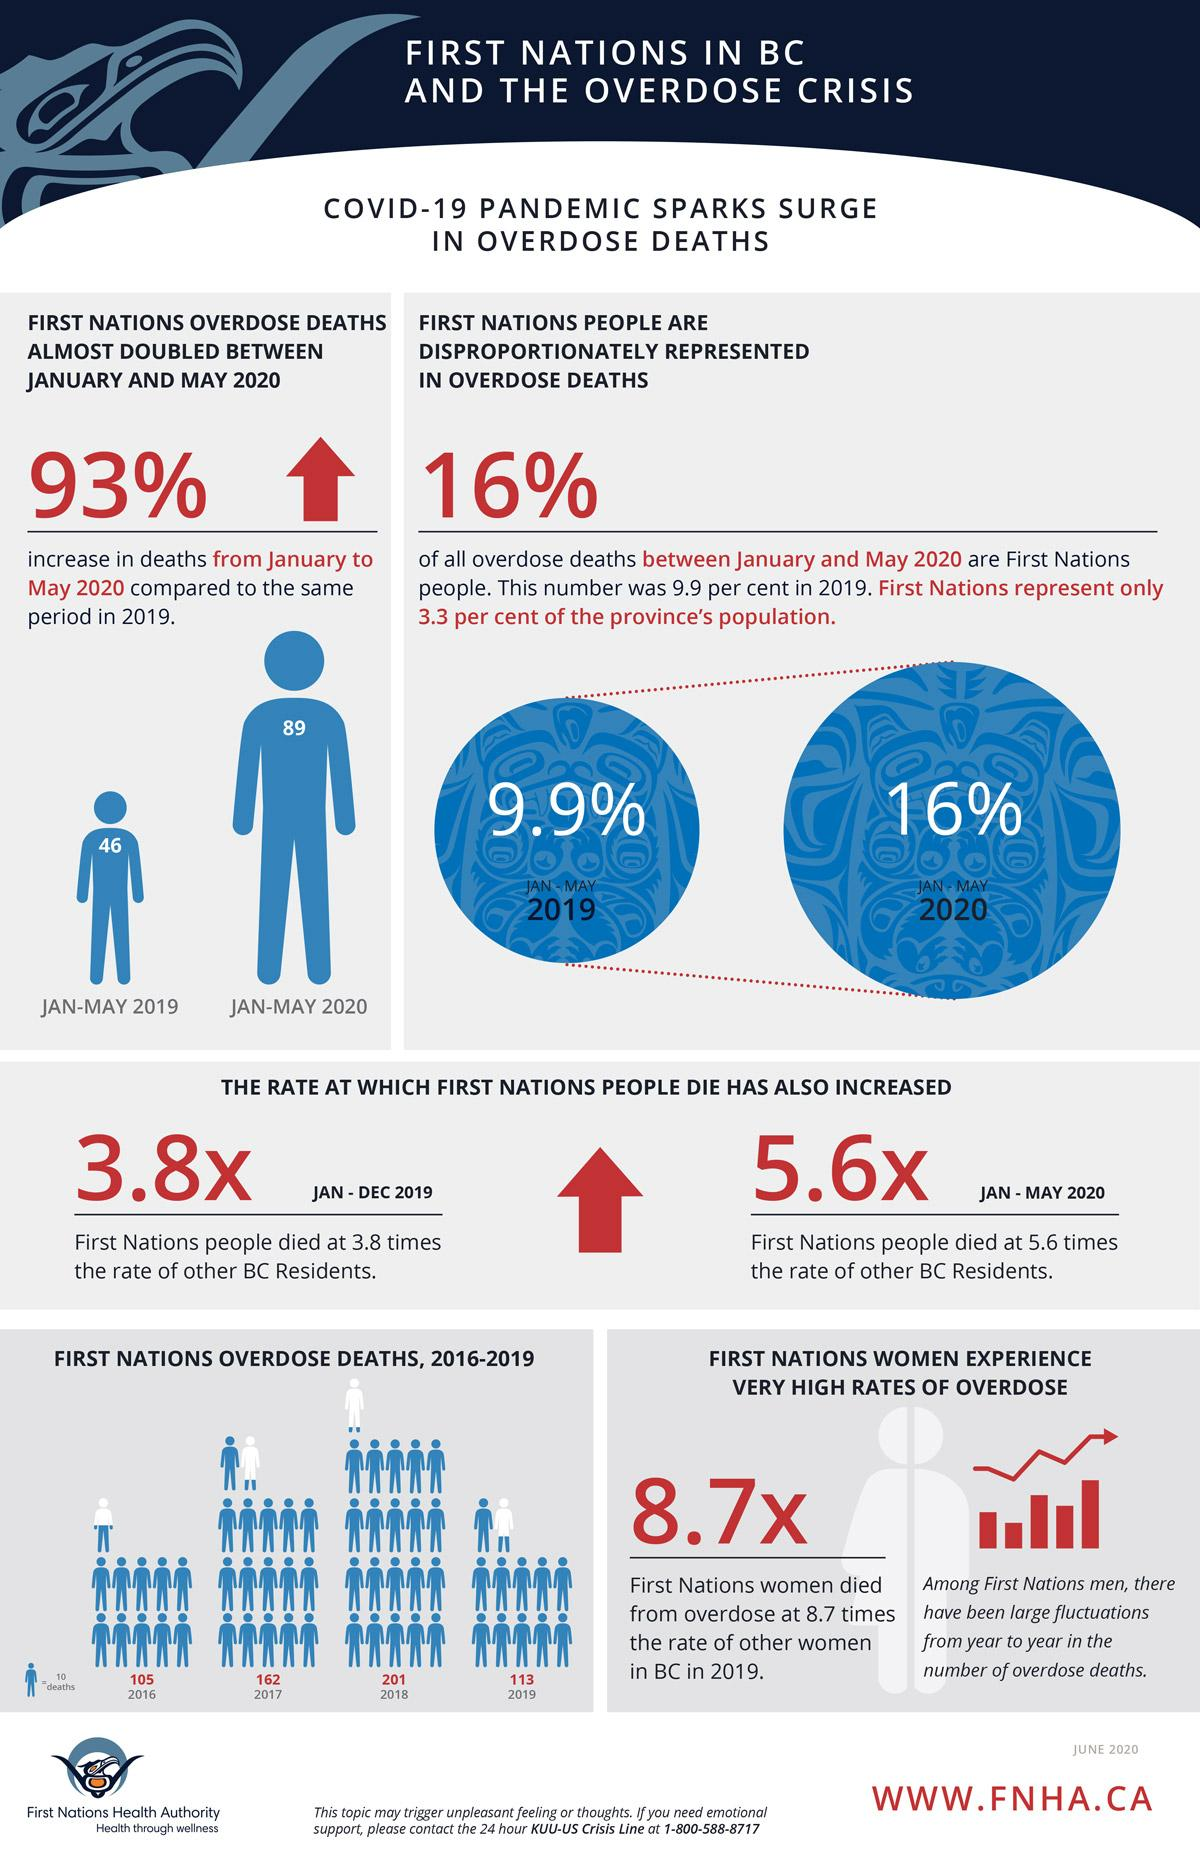Point out several critical features in this image. In 2019, there were 46 deaths among First Nations individuals in Canada. The difference between the death rate of people in 2019 and 2020 is 1.8%. The increase in deaths due to overdose from 2019 to 2020 was 6.1%. The peak year for deaths due to overdose was 2018. In the year 2017, there were 162 First Nation deaths due to overdose. 